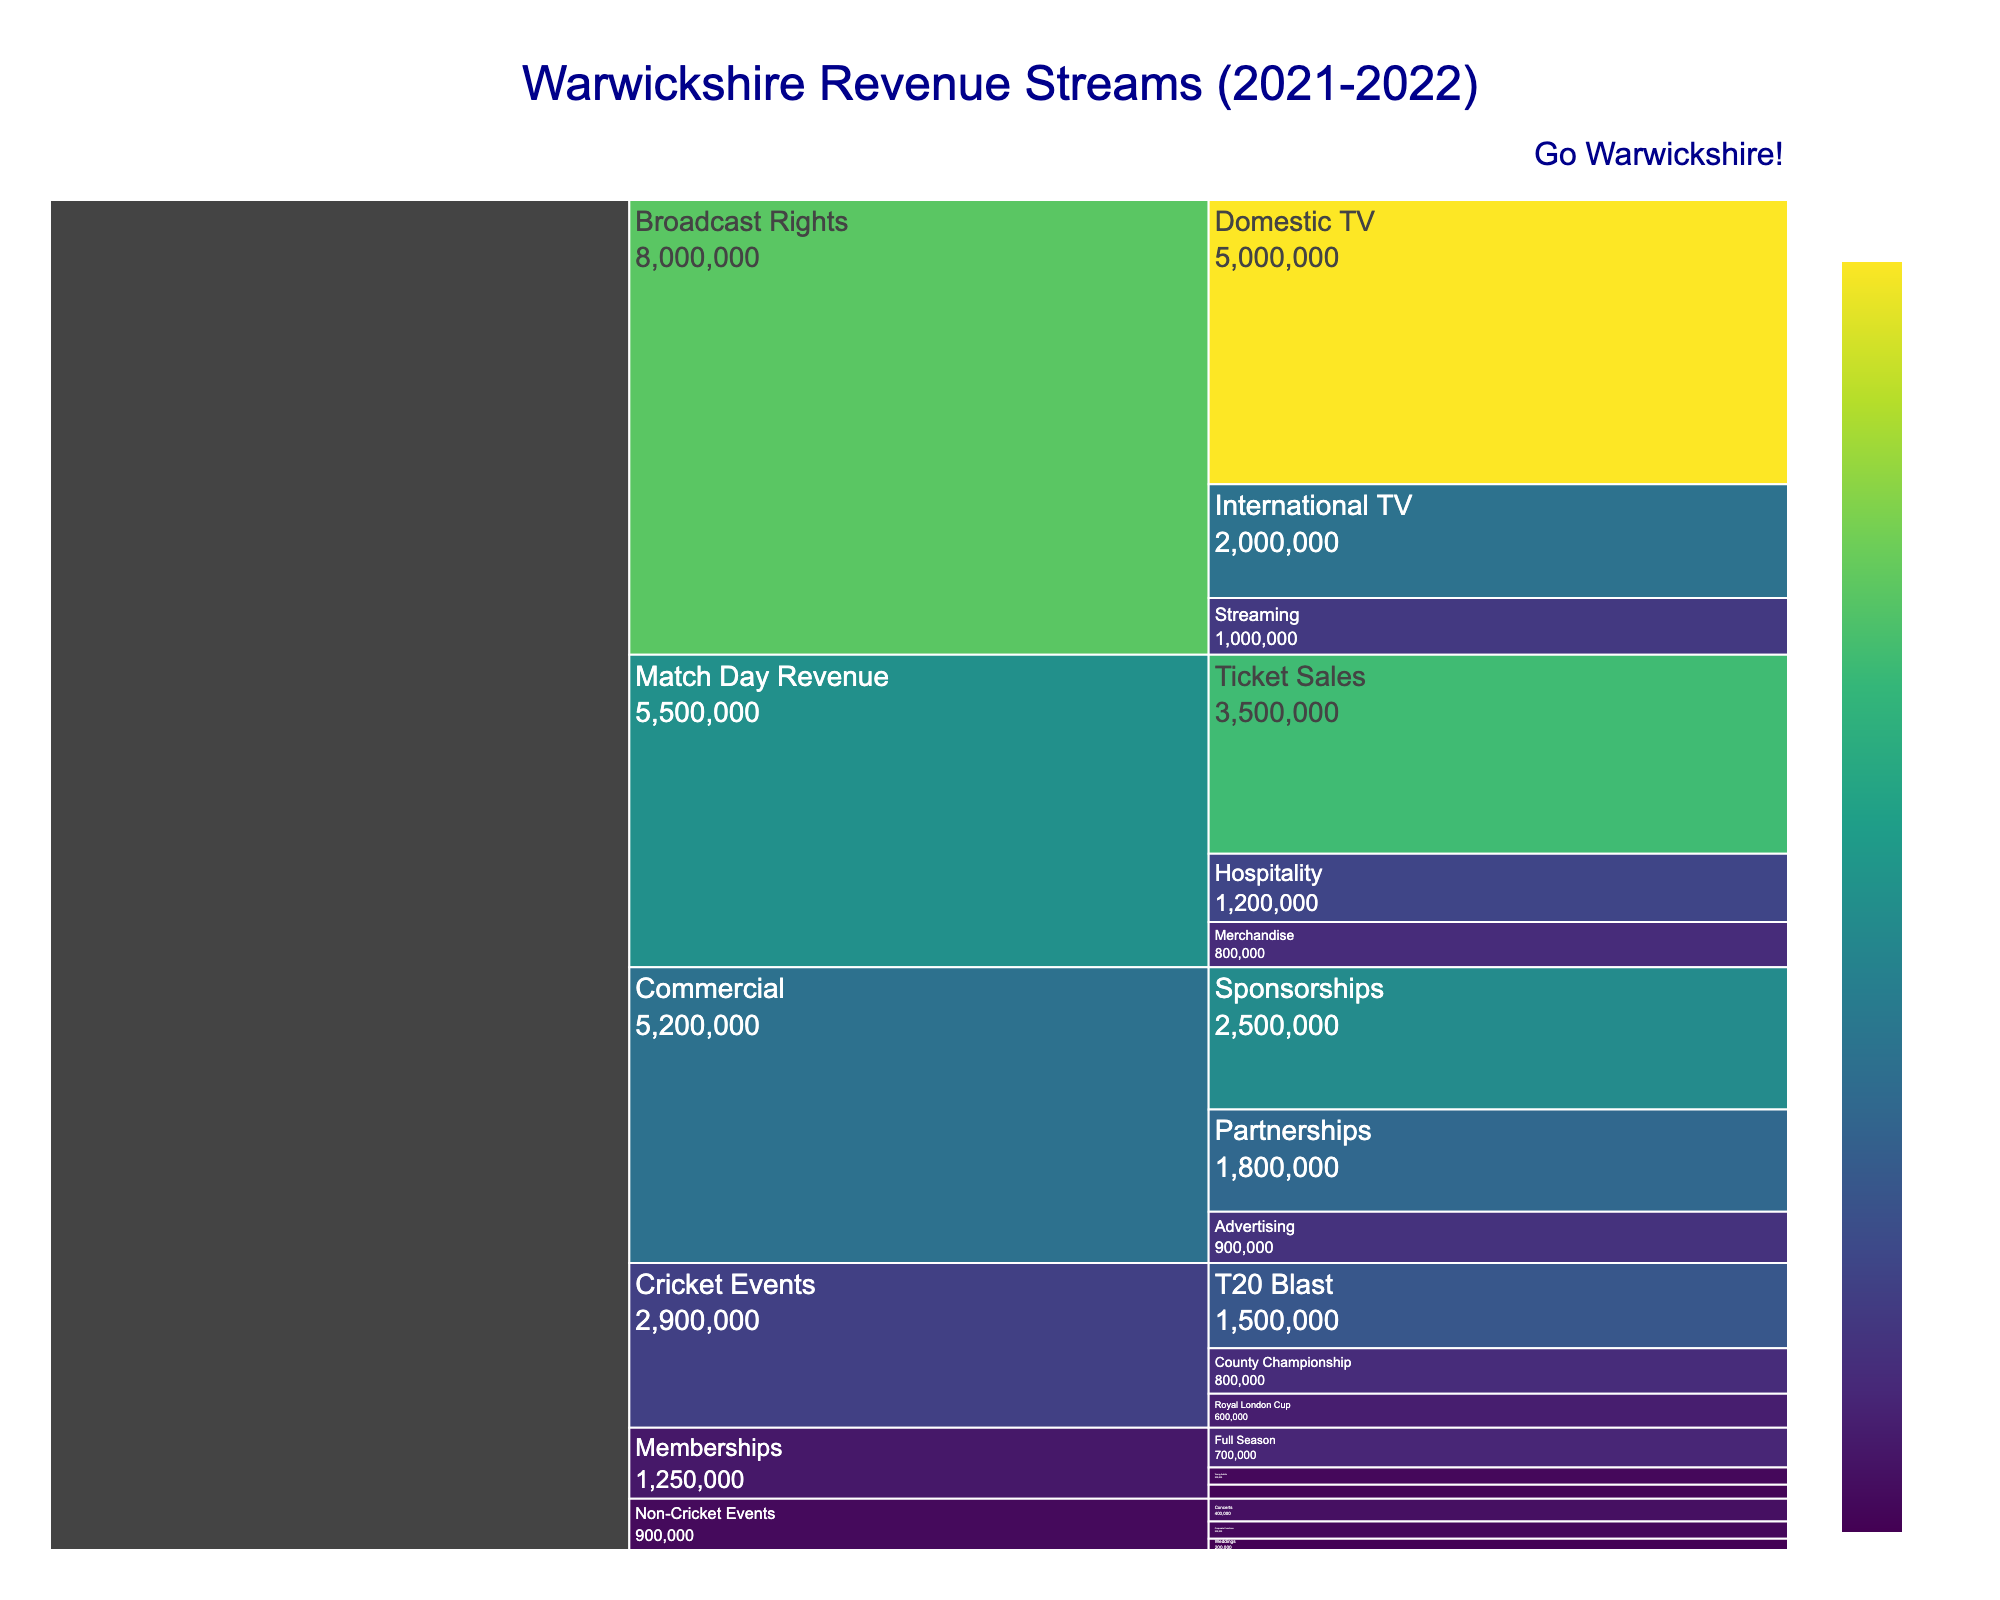What are the main categories shown in the icicle chart? The icicle chart displays revenue streams for Warwickshire categorized into distinct groups. Each segment represents a different category. They are visible as top-level nodes in the chart.
Answer: Match Day Revenue, Broadcast Rights, Commercial, Cricket Events, Non-Cricket Events, Memberships What is the total revenue from Match Day Revenue? To find the total revenue from Match Day Revenue, add the values of all subcategories under Match Day Revenue: Ticket Sales (£3,500,000), Hospitality (£1,200,000), and Merchandise (£800,000).
Answer: £5,500,000 Which sub-category contributed the most revenue to Broadcast Rights? Within Broadcast Rights, compare the values of Domestic TV (£5,000,000), International TV (£2,000,000), and Streaming (£1,000,000). The largest value indicates the highest contributing sub-category.
Answer: Domestic TV What is the combined revenue from Cricket Events and Non-Cricket Events? Add up the revenue from all subcategories under both Cricket Events and Non-Cricket Events: T20 Blast (£1,500,000), County Championship (£800,000), Royal London Cup (£600,000), Concerts (£400,000), Corporate Functions (£300,000), and Weddings (£200,000).
Answer: £3,800,000 Which has higher revenue: Sponsorships or Partnerships? Compare the revenues of Sponsorships (£2,500,000) and Partnerships (£1,800,000) under the Commercial category. The greater value indicates the higher revenue.
Answer: Sponsorships How does the revenue from Full Season Memberships compare to Young Adults Memberships? Compare the revenue from Full Season (£700,000) and Young Adults (£300,000) memberships by examining their individual values. Full Season is greater.
Answer: Full Season What is the revenue difference between International TV and Domestic TV under Broadcast Rights? Subtract the revenue of International TV (£2,000,000) from Domestic TV (£5,000,000) to find the difference.
Answer: £3,000,000 What is the smallest revenue sub-category under Match Day Revenue? Compare the revenue figures for Ticket Sales (£3,500,000), Hospitality (£1,200,000), and Merchandise (£800,000). The smallest revenue corresponds to the lowest figure.
Answer: Merchandise Which non-cricket event generated the least revenue? Compare the revenue figures for Concerts (£400,000), Corporate Functions (£300,000), and Weddings (£200,000). The smallest revenue value indicates the least generating event.
Answer: Weddings How much more revenue did Broadcast Rights generate compared to Memberships? Sum the revenue from all subcategories under Broadcast Rights: (£5,000,000 + £2,000,000 + £1,000,000) = £8,000,000. Then, sum the revenue for Memberships: (£700,000 + £300,000 + £250,000) = £1,250,000. Subtract the total of Memberships from Broadcast Rights to find the difference.
Answer: £6,750,000 